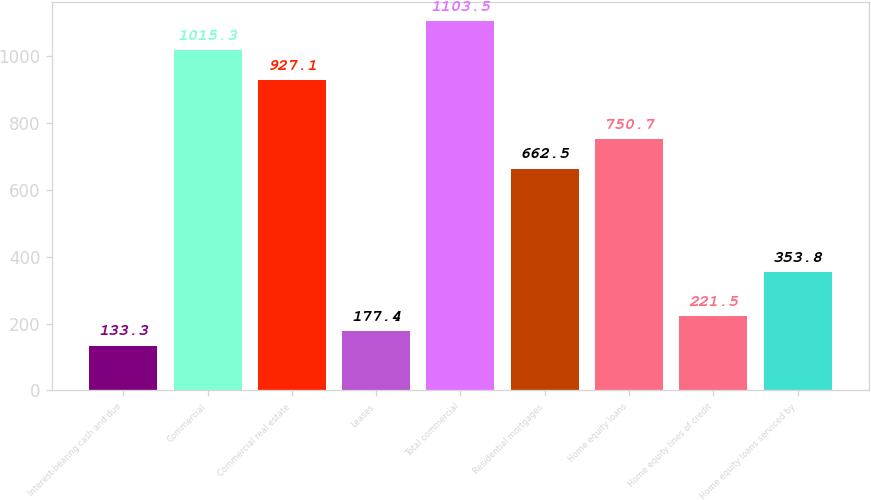Convert chart to OTSL. <chart><loc_0><loc_0><loc_500><loc_500><bar_chart><fcel>Interest-bearing cash and due<fcel>Commercial<fcel>Commercial real estate<fcel>Leases<fcel>Total commercial<fcel>Residential mortgages<fcel>Home equity loans<fcel>Home equity lines of credit<fcel>Home equity loans serviced by<nl><fcel>133.3<fcel>1015.3<fcel>927.1<fcel>177.4<fcel>1103.5<fcel>662.5<fcel>750.7<fcel>221.5<fcel>353.8<nl></chart> 